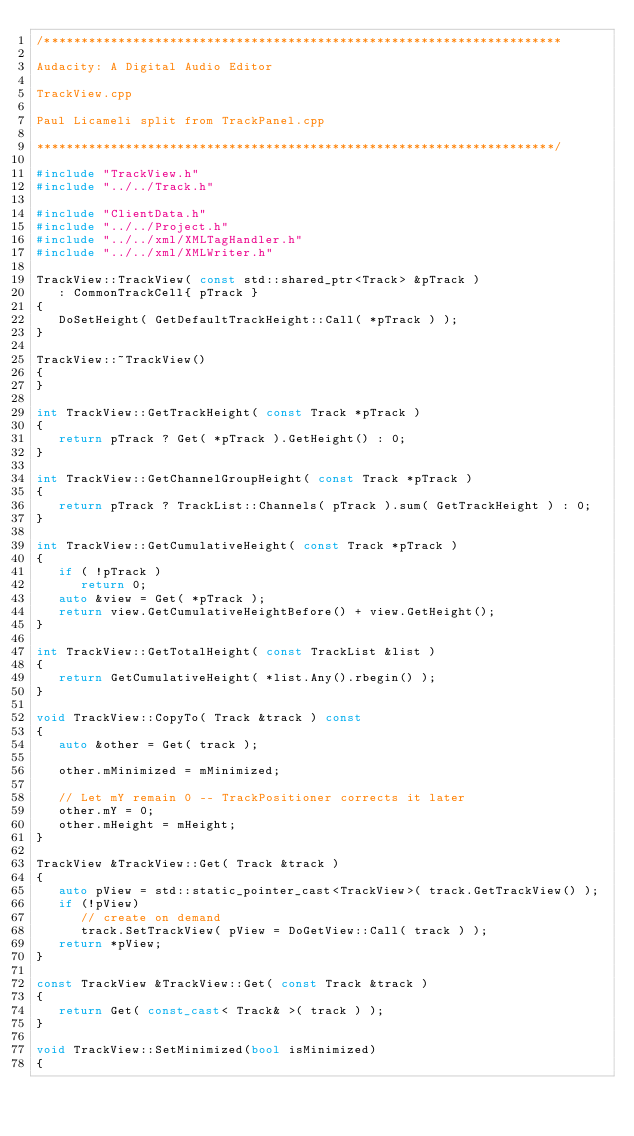<code> <loc_0><loc_0><loc_500><loc_500><_C++_>/**********************************************************************

Audacity: A Digital Audio Editor

TrackView.cpp

Paul Licameli split from TrackPanel.cpp

**********************************************************************/

#include "TrackView.h"
#include "../../Track.h"

#include "ClientData.h"
#include "../../Project.h"
#include "../../xml/XMLTagHandler.h"
#include "../../xml/XMLWriter.h"

TrackView::TrackView( const std::shared_ptr<Track> &pTrack )
   : CommonTrackCell{ pTrack }
{
   DoSetHeight( GetDefaultTrackHeight::Call( *pTrack ) );
}

TrackView::~TrackView()
{
}

int TrackView::GetTrackHeight( const Track *pTrack )
{
   return pTrack ? Get( *pTrack ).GetHeight() : 0;
}

int TrackView::GetChannelGroupHeight( const Track *pTrack )
{
   return pTrack ? TrackList::Channels( pTrack ).sum( GetTrackHeight ) : 0;
}

int TrackView::GetCumulativeHeight( const Track *pTrack )
{
   if ( !pTrack )
      return 0;
   auto &view = Get( *pTrack );
   return view.GetCumulativeHeightBefore() + view.GetHeight();
}

int TrackView::GetTotalHeight( const TrackList &list )
{
   return GetCumulativeHeight( *list.Any().rbegin() );
}

void TrackView::CopyTo( Track &track ) const
{
   auto &other = Get( track );

   other.mMinimized = mMinimized;

   // Let mY remain 0 -- TrackPositioner corrects it later
   other.mY = 0;
   other.mHeight = mHeight;
}

TrackView &TrackView::Get( Track &track )
{
   auto pView = std::static_pointer_cast<TrackView>( track.GetTrackView() );
   if (!pView)
      // create on demand
      track.SetTrackView( pView = DoGetView::Call( track ) );
   return *pView;
}

const TrackView &TrackView::Get( const Track &track )
{
   return Get( const_cast< Track& >( track ) );
}

void TrackView::SetMinimized(bool isMinimized)
{</code> 